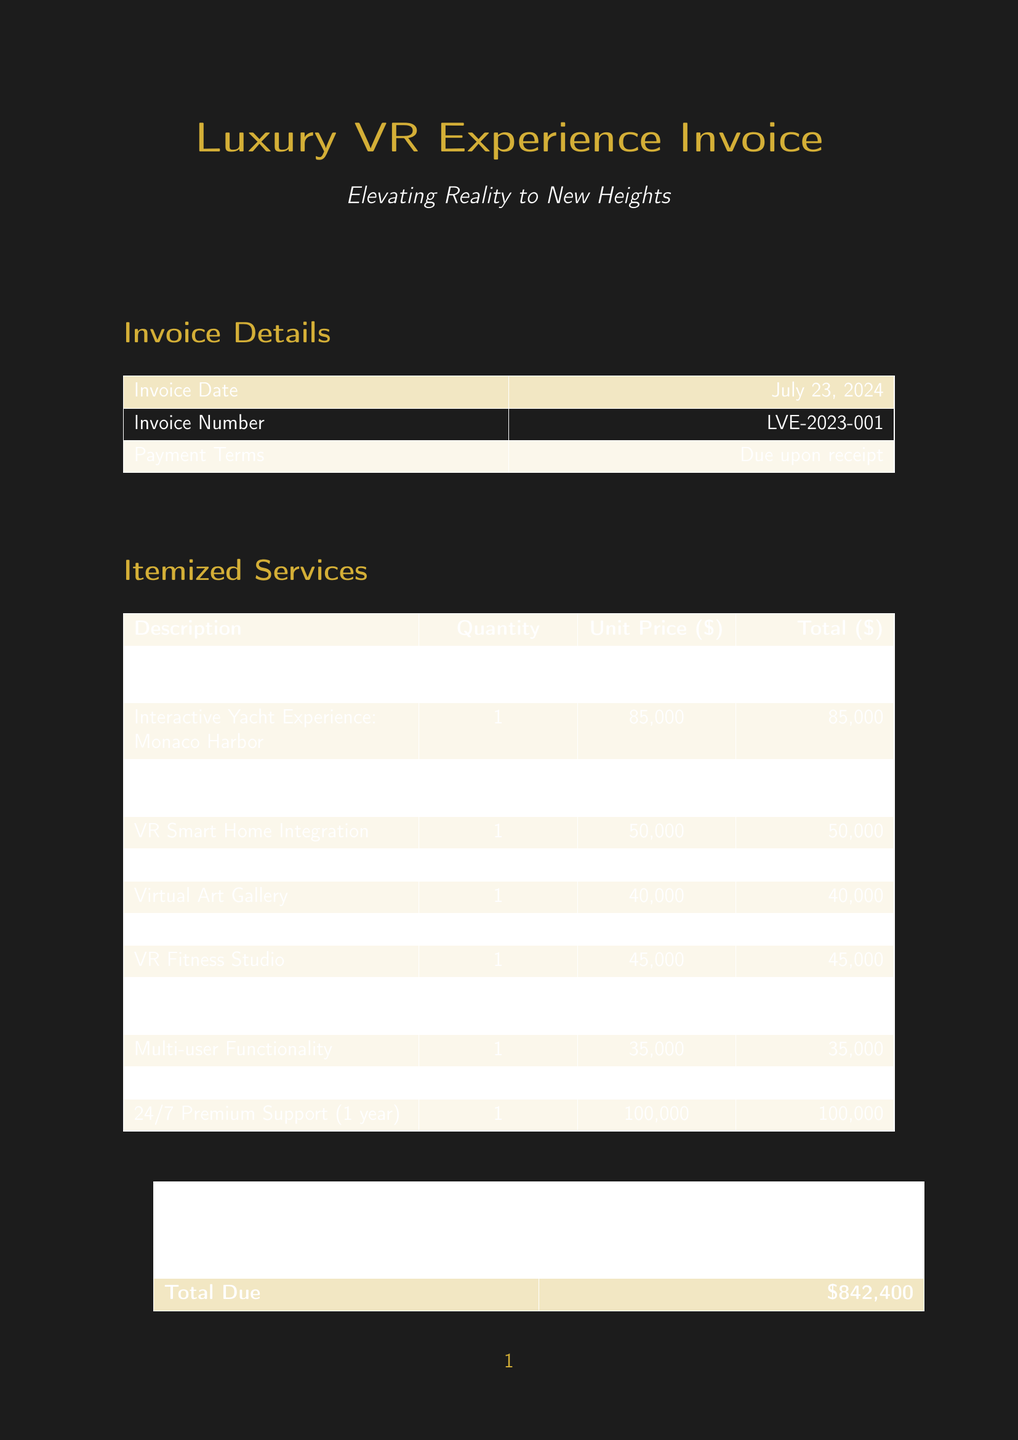What is the invoice number? The invoice number is specified within the document as a unique identifier for the transaction.
Answer: LVE-2023-001 What is the subtotal amount? The subtotal amount is presented as the sum of all item prices before tax.
Answer: $780,000 How many personalized avatars were created? The invoice indicates the quantity of personalized avatars developed for the client.
Answer: 4 What is the unit price of the Luxury Car Showroom? The document states the cost associated with developing the Luxury Car Showroom environment.
Answer: 60,000 What is the tax rate applied to the invoice? The tax rate indicates the percentage added to the subtotal in the invoice totals section.
Answer: 8% What is the total due amount? The total due is the final amount that the client is required to pay after tax is added to the subtotal.
Answer: $842,400 What service is included in 24/7 Premium Support? This refers to continuous technical assistance and maintenance for the VR systems listed in the invoice.
Answer: One year What is the total price for the Custom VR Environment of Amalfi Coast Villa? The total price for each specific item is listed in the invoice, which includes the Amalfi Coast Environment.
Answer: 75,000 What kind of experience is the Private Island Getaway based on? The description outlines that this environment is inspired by luxury resorts found in a specific location.
Answer: Maldives 